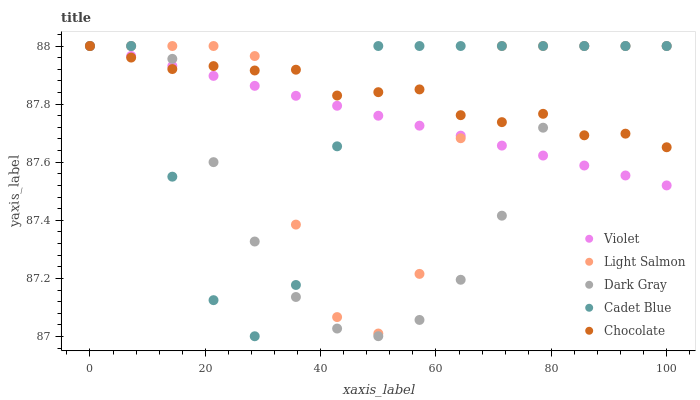Does Dark Gray have the minimum area under the curve?
Answer yes or no. Yes. Does Chocolate have the maximum area under the curve?
Answer yes or no. Yes. Does Light Salmon have the minimum area under the curve?
Answer yes or no. No. Does Light Salmon have the maximum area under the curve?
Answer yes or no. No. Is Violet the smoothest?
Answer yes or no. Yes. Is Light Salmon the roughest?
Answer yes or no. Yes. Is Chocolate the smoothest?
Answer yes or no. No. Is Chocolate the roughest?
Answer yes or no. No. Does Cadet Blue have the lowest value?
Answer yes or no. Yes. Does Light Salmon have the lowest value?
Answer yes or no. No. Does Violet have the highest value?
Answer yes or no. Yes. Does Light Salmon intersect Chocolate?
Answer yes or no. Yes. Is Light Salmon less than Chocolate?
Answer yes or no. No. Is Light Salmon greater than Chocolate?
Answer yes or no. No. 